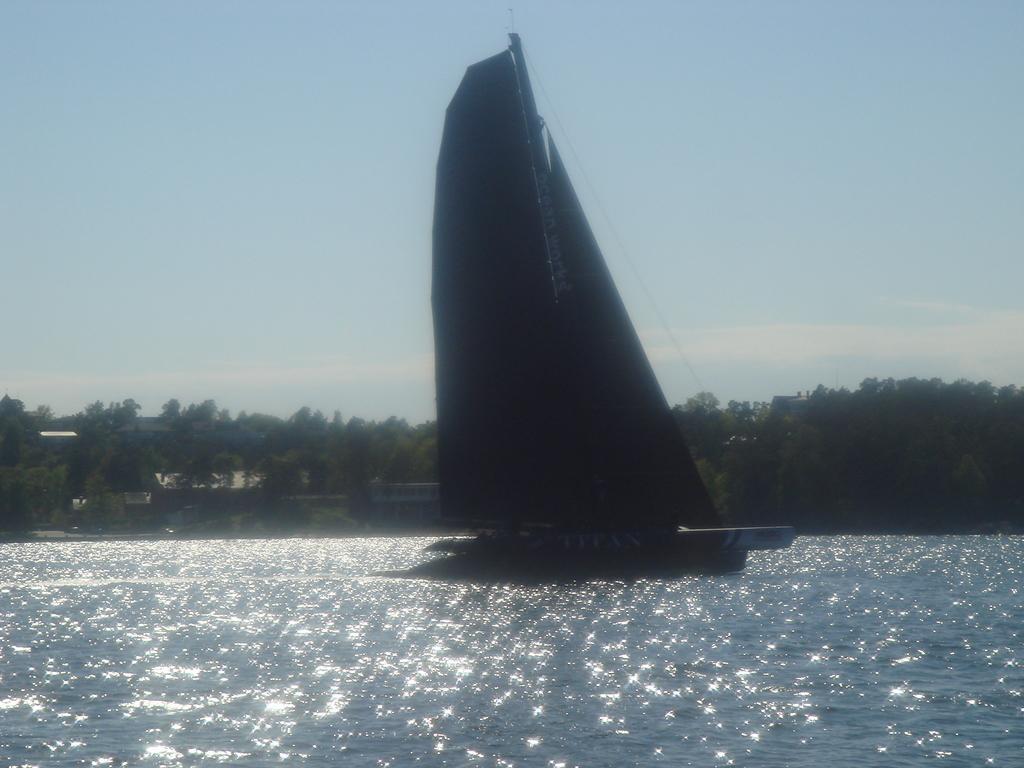In one or two sentences, can you explain what this image depicts? There is a boat, which is having mast on the water. In the background, there are trees, plants and clouds in the blue sky. 